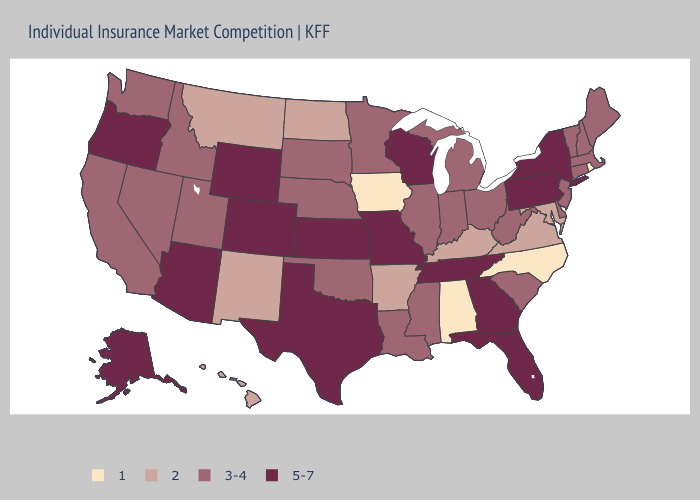Which states have the highest value in the USA?
Answer briefly. Alaska, Arizona, Colorado, Florida, Georgia, Kansas, Missouri, New York, Oregon, Pennsylvania, Tennessee, Texas, Wisconsin, Wyoming. What is the highest value in the Northeast ?
Write a very short answer. 5-7. What is the highest value in the MidWest ?
Keep it brief. 5-7. What is the lowest value in the USA?
Keep it brief. 1. Which states have the highest value in the USA?
Keep it brief. Alaska, Arizona, Colorado, Florida, Georgia, Kansas, Missouri, New York, Oregon, Pennsylvania, Tennessee, Texas, Wisconsin, Wyoming. Name the states that have a value in the range 5-7?
Quick response, please. Alaska, Arizona, Colorado, Florida, Georgia, Kansas, Missouri, New York, Oregon, Pennsylvania, Tennessee, Texas, Wisconsin, Wyoming. Name the states that have a value in the range 3-4?
Keep it brief. California, Connecticut, Delaware, Idaho, Illinois, Indiana, Louisiana, Maine, Massachusetts, Michigan, Minnesota, Mississippi, Nebraska, Nevada, New Hampshire, New Jersey, Ohio, Oklahoma, South Carolina, South Dakota, Utah, Vermont, Washington, West Virginia. Name the states that have a value in the range 5-7?
Keep it brief. Alaska, Arizona, Colorado, Florida, Georgia, Kansas, Missouri, New York, Oregon, Pennsylvania, Tennessee, Texas, Wisconsin, Wyoming. Name the states that have a value in the range 1?
Write a very short answer. Alabama, Iowa, North Carolina, Rhode Island. What is the value of Kansas?
Be succinct. 5-7. Does Oregon have the highest value in the West?
Keep it brief. Yes. Among the states that border Georgia , which have the lowest value?
Concise answer only. Alabama, North Carolina. What is the value of Arkansas?
Concise answer only. 2. Does New Hampshire have the same value as Georgia?
Quick response, please. No. Does Oregon have the lowest value in the West?
Quick response, please. No. 